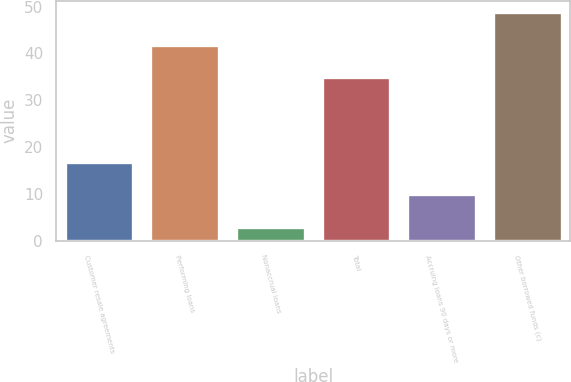Convert chart. <chart><loc_0><loc_0><loc_500><loc_500><bar_chart><fcel>Customer resale agreements<fcel>Performing loans<fcel>Nonaccrual loans<fcel>Total<fcel>Accruing loans 90 days or more<fcel>Other borrowed funds (c)<nl><fcel>16.8<fcel>41.9<fcel>3<fcel>35<fcel>9.9<fcel>48.8<nl></chart> 